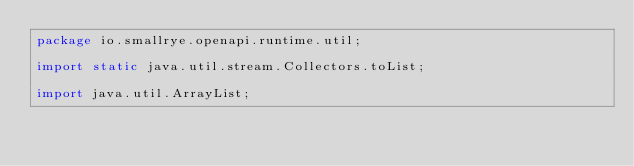Convert code to text. <code><loc_0><loc_0><loc_500><loc_500><_Java_>package io.smallrye.openapi.runtime.util;

import static java.util.stream.Collectors.toList;

import java.util.ArrayList;</code> 